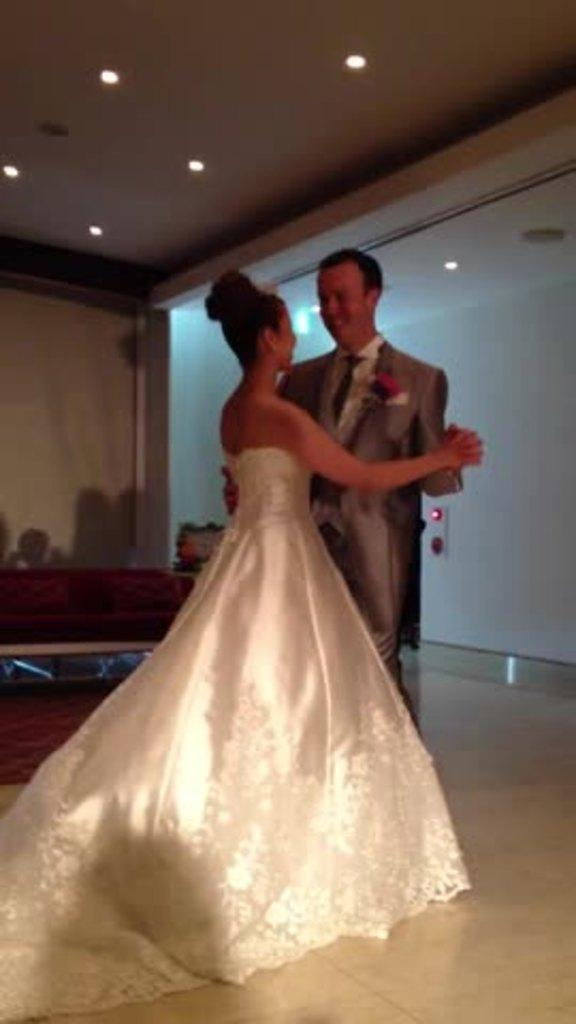How many people are in the image? There are two people in the image. What are the two people doing in the image? The two people are dancing on the floor. What is behind the people in the image? There is a wall behind the people, and objects are visible behind them. What type of lighting is present in the image? Ceiling lights are present at the top of the image. How many doors can be seen in the image? There are no doors visible in the image. What type of guide is present in the image? There is no guide present in the image. 